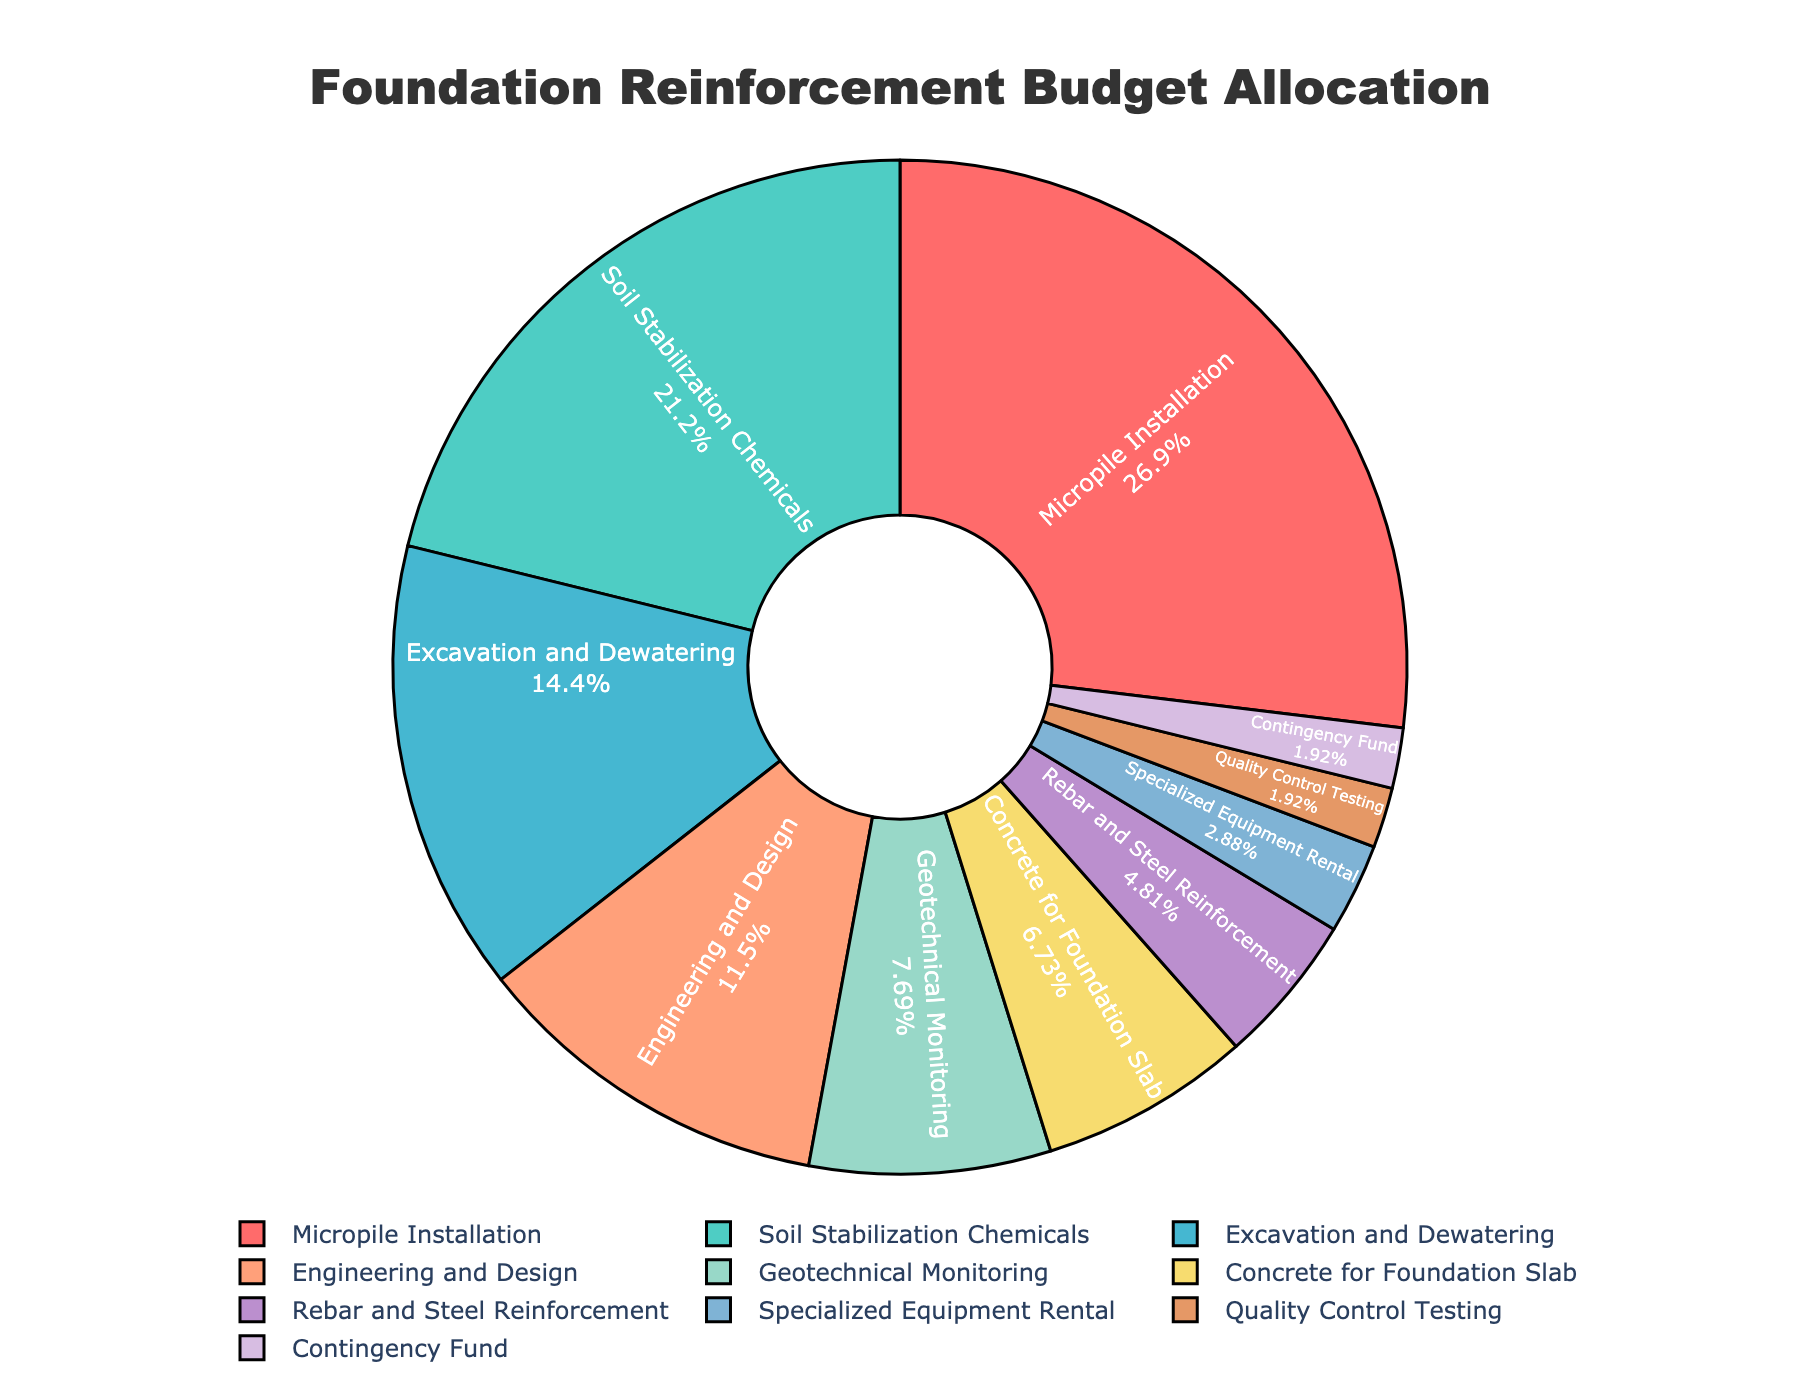What's the largest budget category? The largest segment in the pie chart is for "Micropile Installation" which takes up 28% of the budget.
Answer: Micropile Installation Which category has the lowest budget allocation? The smallest segment in the pie chart is the "Contingency Fund," which allocates 2% of the budget.
Answer: Contingency Fund What is the combined budget percentage for the categories under 10%? Categories under 10% include "Geotechnical Monitoring" (8%), "Concrete for Foundation Slab" (7%), "Rebar and Steel Reinforcement" (5%), "Specialized Equipment Rental" (3%), "Quality Control Testing" (2%), and "Contingency Fund" (2%). Adding these gives 8 + 7 + 5 + 3 + 2 + 2 = 27%.
Answer: 27% How does the allocation for "Soil Stabilization Chemicals" compare to "Concrete for Foundation Slab"? Soil Stabilization Chemicals is 22%, while Concrete for Foundation Slab is 7%. Therefore, Soil Stabilization Chemicals has a larger budget allocation.
Answer: Soil Stabilization Chemicals has a larger allocation What is the relative difference between the largest and smallest categories? The largest category is "Micropile Installation" at 28%, and the smallest is "Contingency Fund" at 2%. The difference is 28% - 2% = 26%.
Answer: 26% How does the budget for "Engineering and Design" compare to "Excavation and Dewatering"? Engineering and Design allocates 12%, while Excavation and Dewatering allocates 15%. Excavation and Dewatering has a larger budget by 3%.
Answer: Excavation and Dewatering is larger by 3% What categories allocate above 20% of the budget? The categories with allocations above 20% are "Micropile Installation" (28%) and "Soil Stabilization Chemicals" (22%).
Answer: Micropile Installation and Soil Stabilization Chemicals Which category has the third-highest budget allocation? After Micropile Installation (28%) and Soil Stabilization Chemicals (22%), the next highest allocation is "Excavation and Dewatering" at 15%.
Answer: Excavation and Dewatering What percentage of the budget is allocated to "Quality Control Testing" and "Contingency Fund" combined? Quality Control Testing and Contingency Fund each get 2%, so combined they make 2% + 2% = 4%.
Answer: 4% What is the total budget percentage spent on reinforcement materials like "Concrete for Foundation Slab" and "Rebar and Steel Reinforcement"? Concrete for Foundation Slab is 7% and Rebar and Steel Reinforcement is 5%. Summing these gives 7% + 5% = 12%.
Answer: 12% 